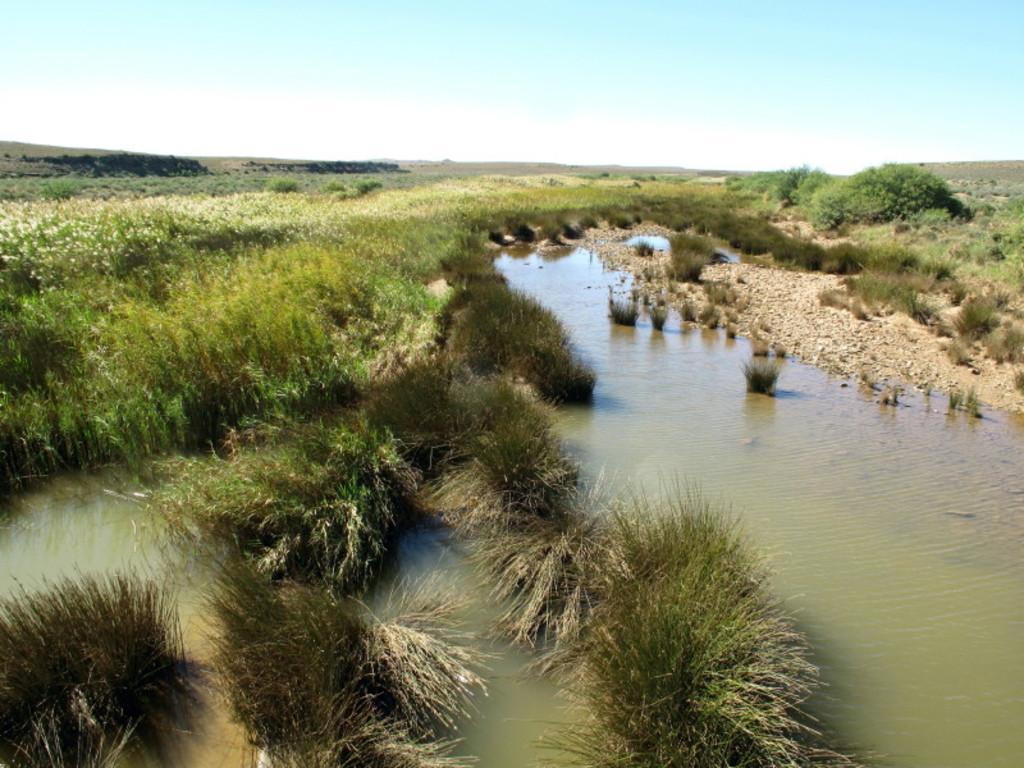Please provide a concise description of this image. In this image I can see a lake and tree and the sky. 